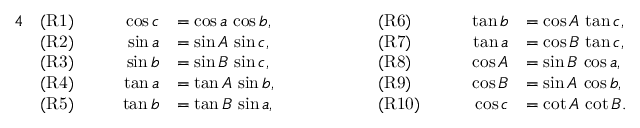<formula> <loc_0><loc_0><loc_500><loc_500>{ \begin{array} { r l r l r l r l } { 4 } & { ( R 1 ) } & { \quad \cos c } & { = \cos a \, \cos b , } & { \quad } & { ( R 6 ) } & { \quad \tan b } & { = \cos A \, \tan c , } \\ & { ( R 2 ) } & { \sin a } & { = \sin A \, \sin c , } & & { ( R 7 ) } & { \tan a } & { = \cos B \, \tan c , } \\ & { ( R 3 ) } & { \sin b } & { = \sin B \, \sin c , } & & { ( R 8 ) } & { \cos A } & { = \sin B \, \cos a , } \\ & { ( R 4 ) } & { \tan a } & { = \tan A \, \sin b , } & & { ( R 9 ) } & { \cos B } & { = \sin A \, \cos b , } \\ & { ( R 5 ) } & { \tan b } & { = \tan B \, \sin a , } & & { ( R 1 0 ) } & { \cos c } & { = \cot A \, \cot B . } \end{array} }</formula> 